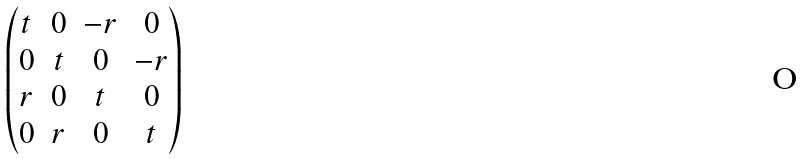Convert formula to latex. <formula><loc_0><loc_0><loc_500><loc_500>\begin{pmatrix} t & 0 & - r & 0 \\ 0 & t & 0 & - r \\ r & 0 & t & 0 \\ 0 & r & 0 & t \end{pmatrix}</formula> 